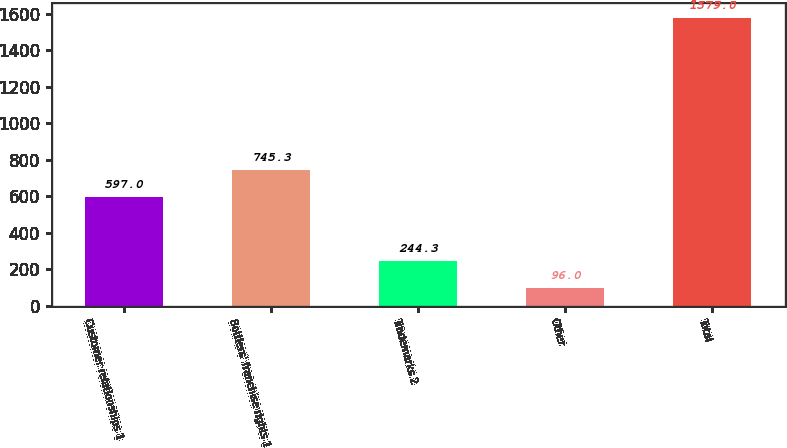Convert chart to OTSL. <chart><loc_0><loc_0><loc_500><loc_500><bar_chart><fcel>Customer relationships 1<fcel>Bottlers' franchise rights 1<fcel>Trademarks 2<fcel>Other<fcel>Total<nl><fcel>597<fcel>745.3<fcel>244.3<fcel>96<fcel>1579<nl></chart> 